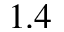Convert formula to latex. <formula><loc_0><loc_0><loc_500><loc_500>1 . 4</formula> 